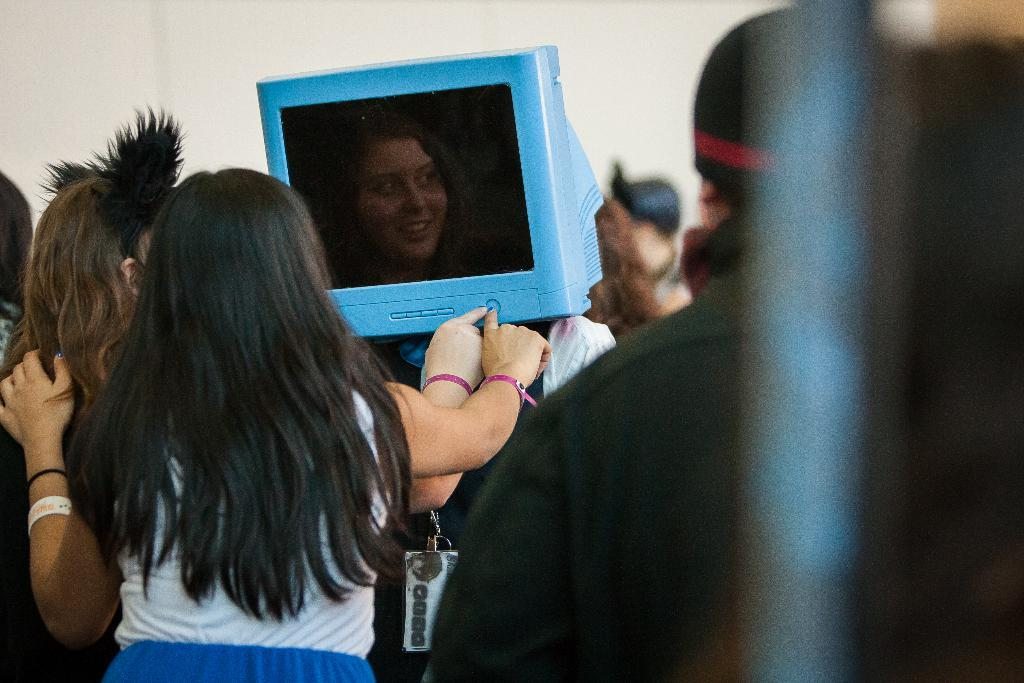How many people are in the image? There is a group of people in the image. What object can be seen in the image that is typically used for entertainment? There is a television in the image. What feature of the television is mentioned in the facts? The television has a screen. What can be seen in the background of the image? There is a wall in the background of the image. What action are two people performing in the image? Two people are pressing a button in the image. What type of underwear is visible on the people in the image? There is no information about underwear in the image, so we cannot determine what type of underwear the people are wearing. Can you describe the waves in the image? There are no waves present in the image; it features a group of people, a television, and a wall in the background. 